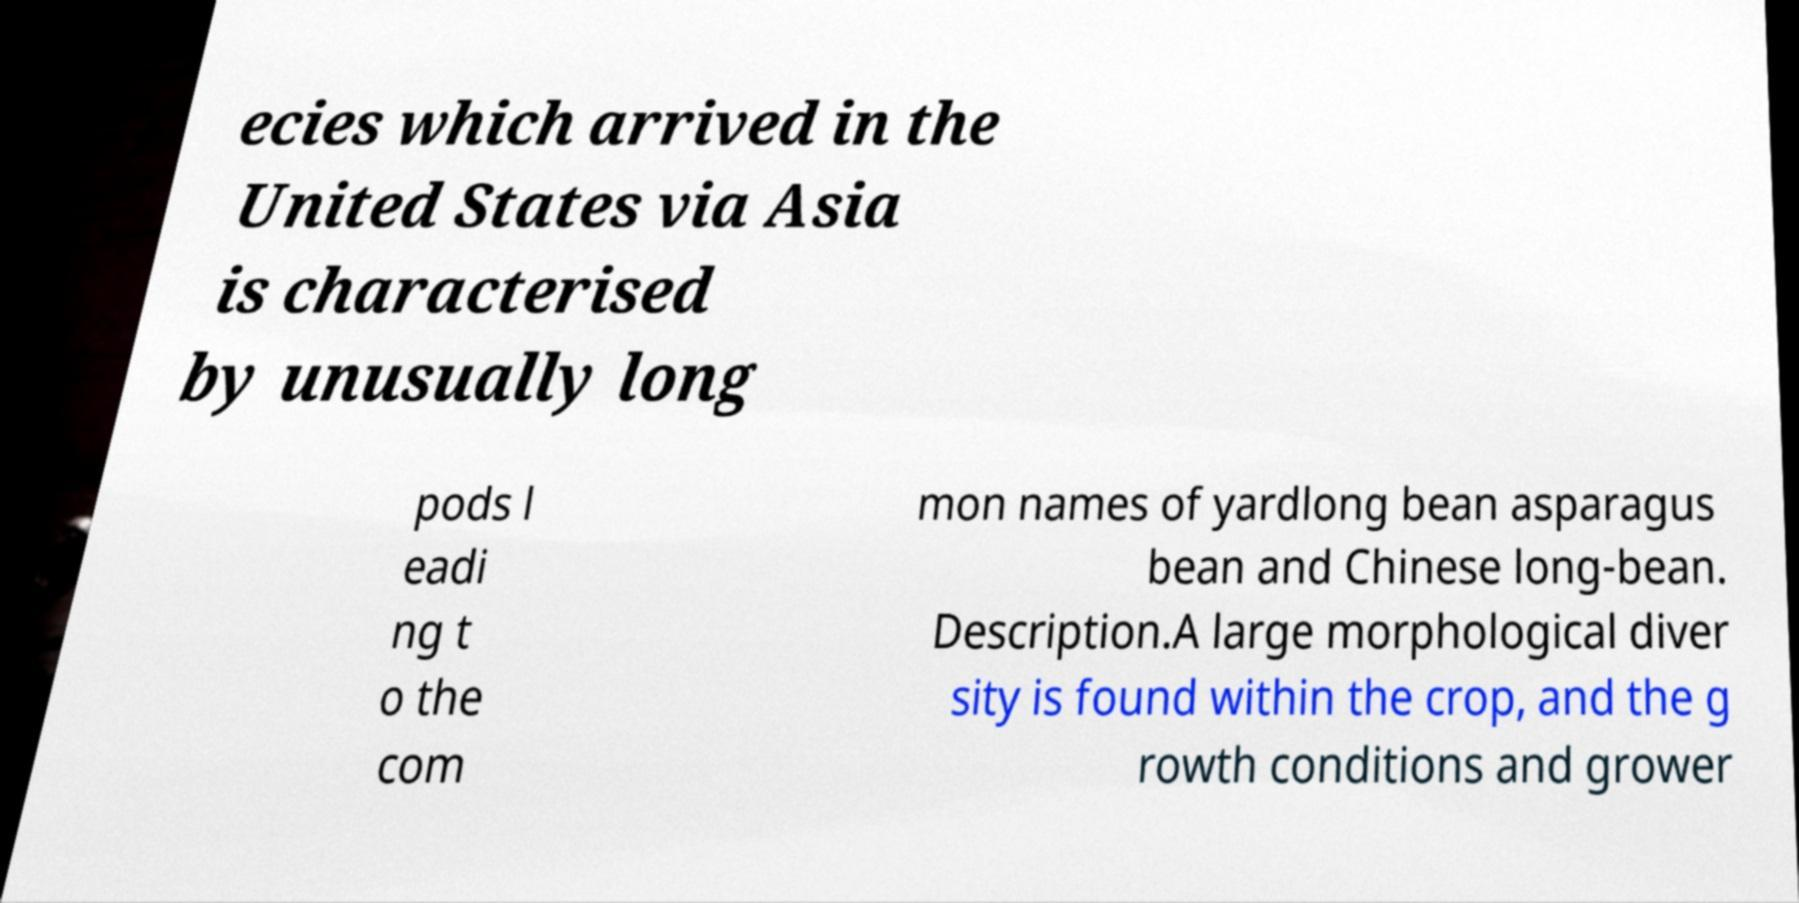For documentation purposes, I need the text within this image transcribed. Could you provide that? ecies which arrived in the United States via Asia is characterised by unusually long pods l eadi ng t o the com mon names of yardlong bean asparagus bean and Chinese long-bean. Description.A large morphological diver sity is found within the crop, and the g rowth conditions and grower 